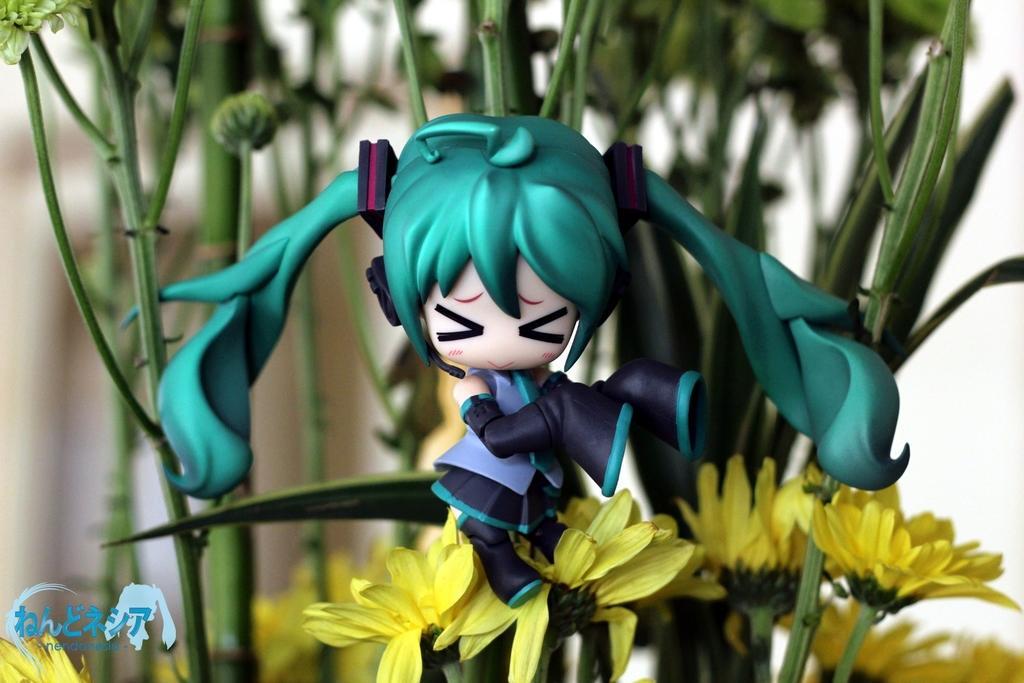Describe this image in one or two sentences. In this picture, we can see some plants, flowers, a doll, and we can see a watermark in the bottom left corner, and we can see the blurred background. 